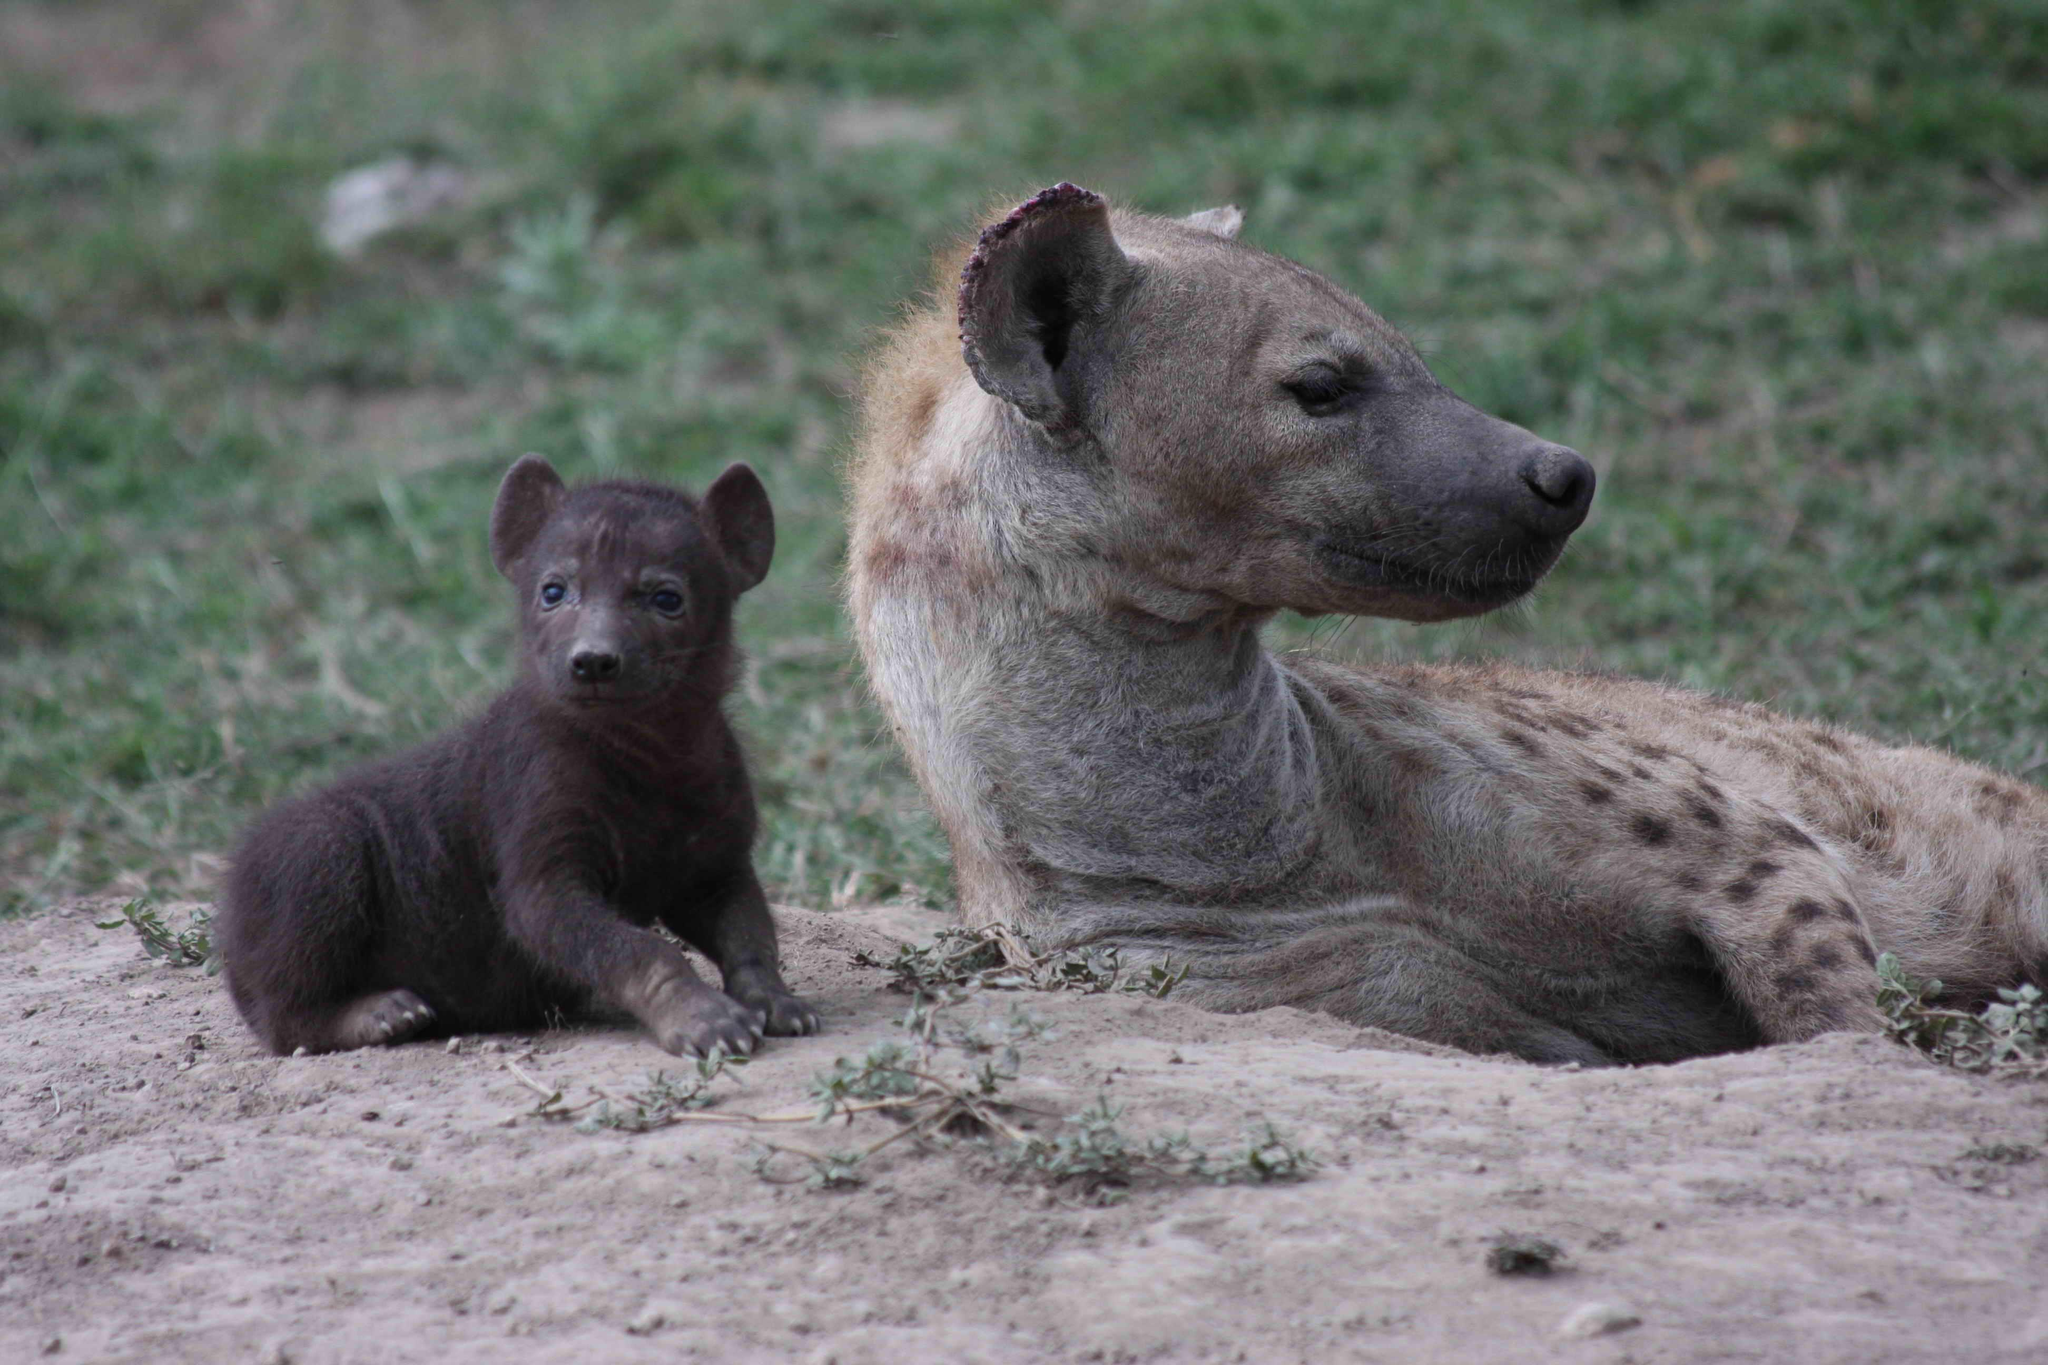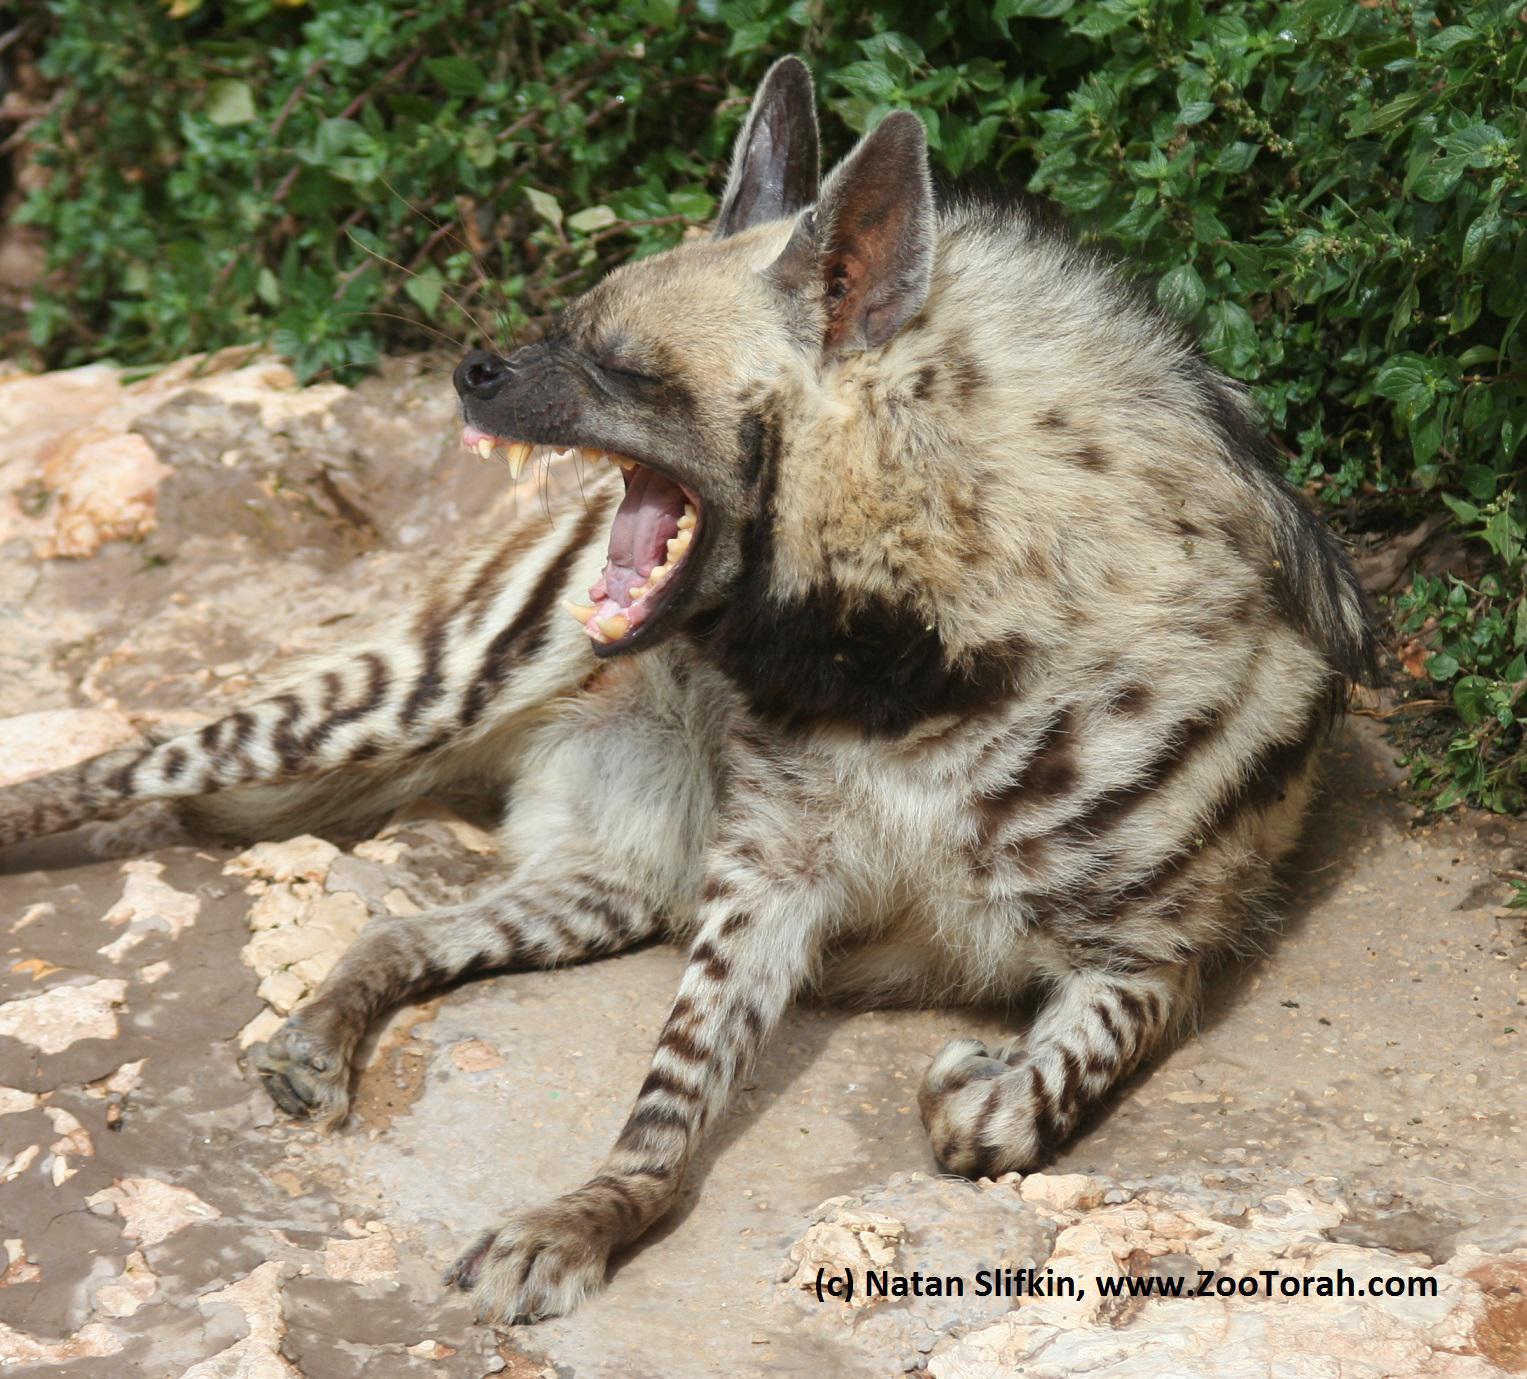The first image is the image on the left, the second image is the image on the right. Evaluate the accuracy of this statement regarding the images: "The left image contains one adult hyena and one baby hyena.". Is it true? Answer yes or no. Yes. The first image is the image on the left, the second image is the image on the right. For the images shown, is this caption "Exactly one of the images shows hyenas in a wet area." true? Answer yes or no. No. 